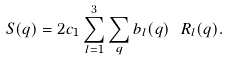Convert formula to latex. <formula><loc_0><loc_0><loc_500><loc_500>S ( { q } ) = 2 c _ { 1 } \sum _ { l = 1 } ^ { 3 } \sum _ { q } b _ { l } ( { q } ) \ R _ { l } ( { q } ) .</formula> 